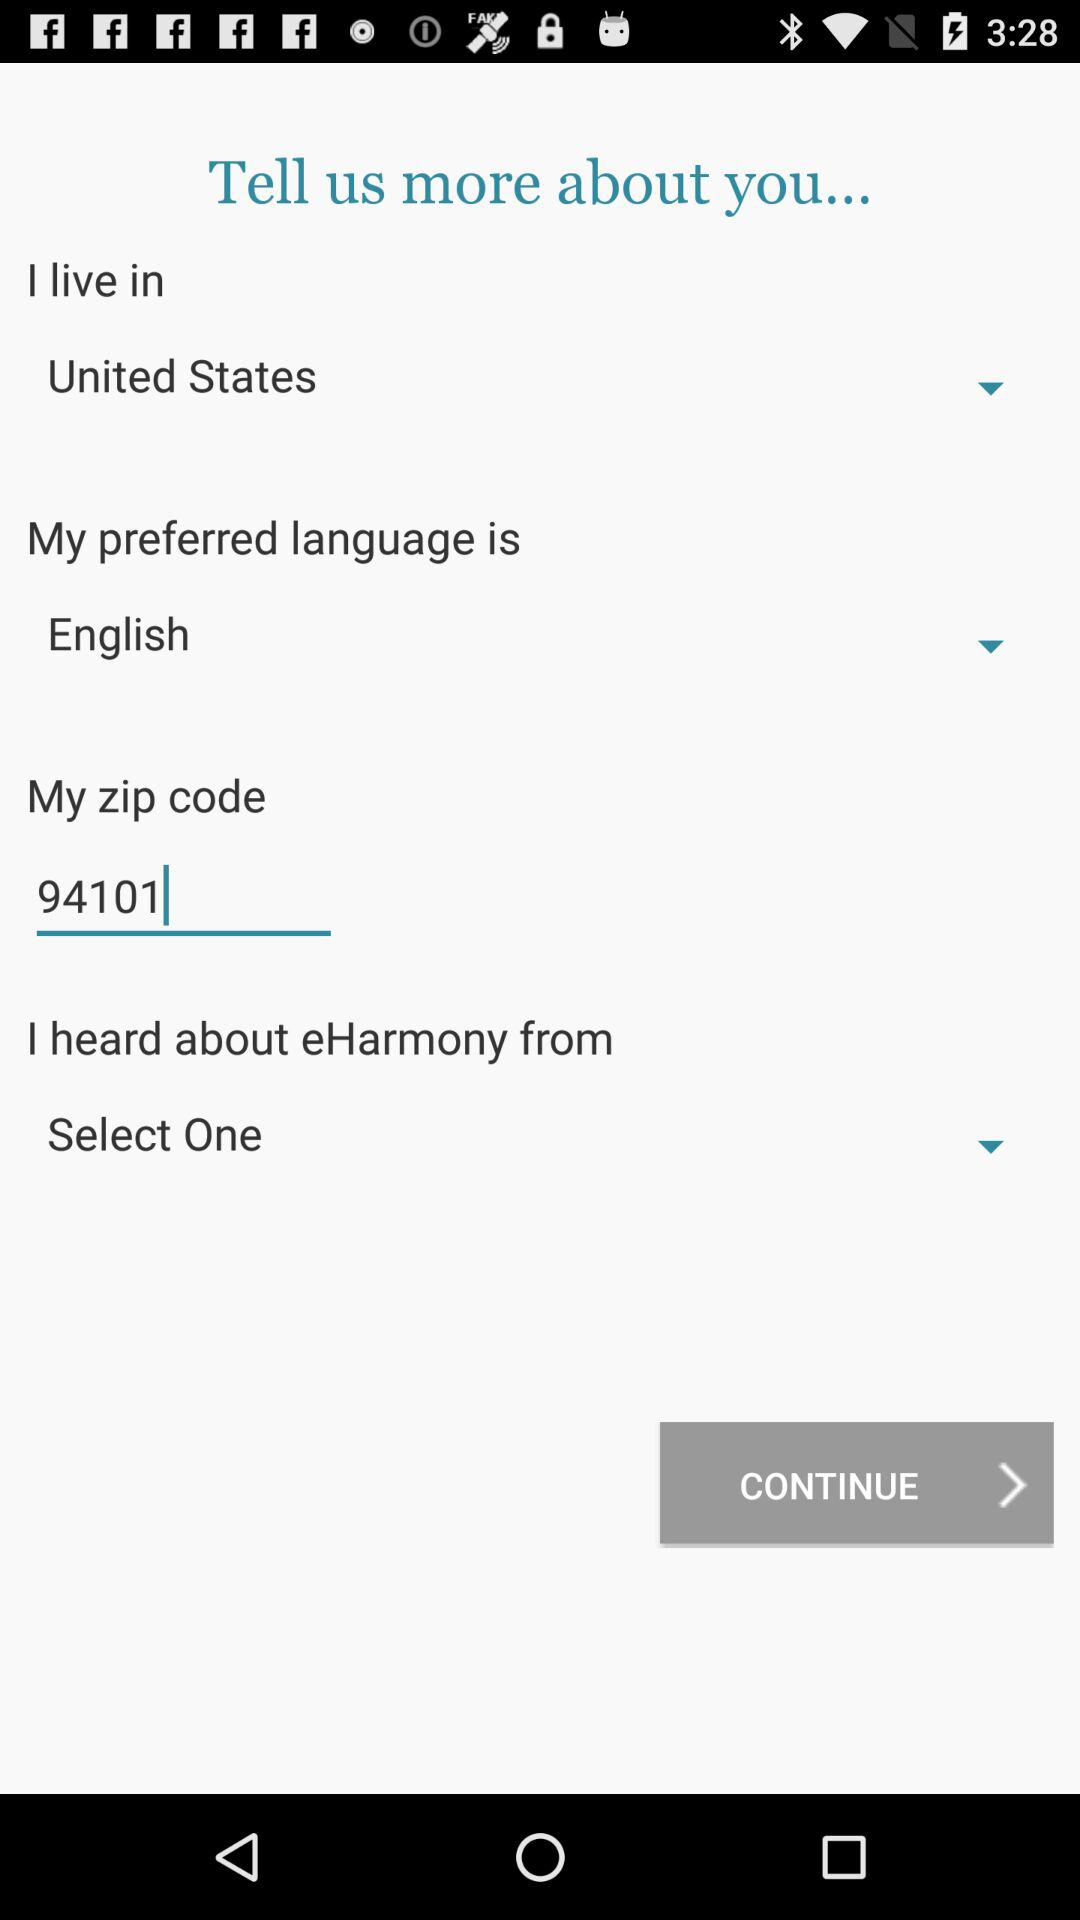What is the selected language? The selected language is English. 